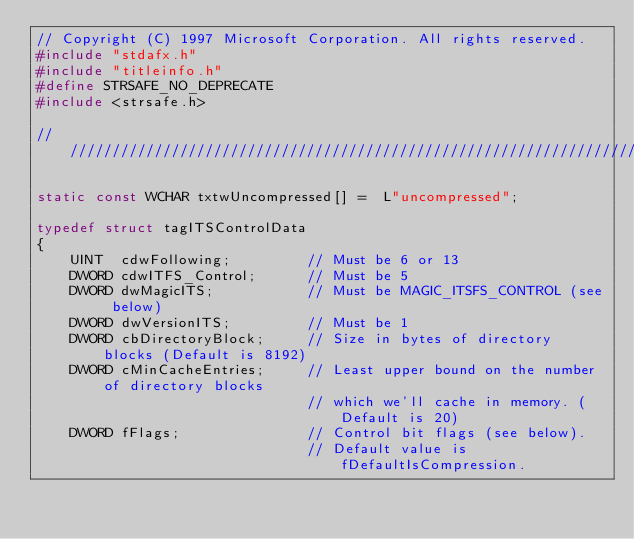<code> <loc_0><loc_0><loc_500><loc_500><_C++_>// Copyright (C) 1997 Microsoft Corporation. All rights reserved.
#include "stdafx.h"
#include "titleinfo.h"
#define STRSAFE_NO_DEPRECATE
#include <strsafe.h>

////////////////////////////////////////////////////////////////////////////////

static const WCHAR txtwUncompressed[] =  L"uncompressed";

typedef struct tagITSControlData
{
    UINT  cdwFollowing;         // Must be 6 or 13
    DWORD cdwITFS_Control;      // Must be 5
    DWORD dwMagicITS;           // Must be MAGIC_ITSFS_CONTROL (see below)
    DWORD dwVersionITS;         // Must be 1
    DWORD cbDirectoryBlock;     // Size in bytes of directory blocks (Default is 8192)
    DWORD cMinCacheEntries;     // Least upper bound on the number of directory blocks
                                // which we'll cache in memory. (Default is 20)
    DWORD fFlags;               // Control bit flags (see below).
                                // Default value is fDefaultIsCompression.</code> 